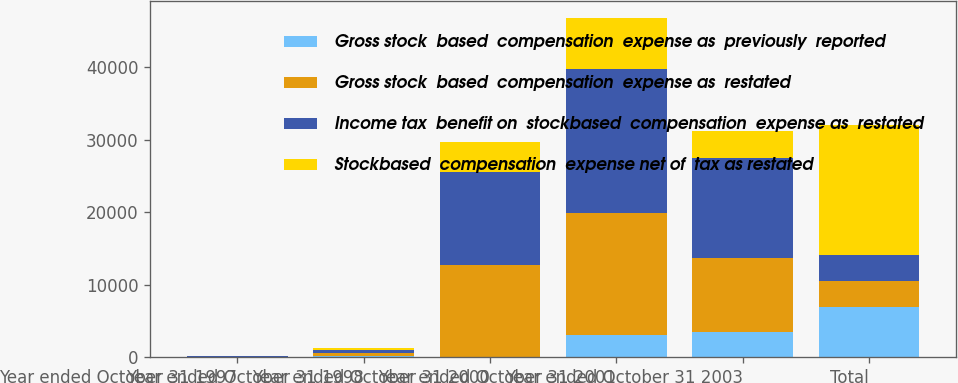Convert chart to OTSL. <chart><loc_0><loc_0><loc_500><loc_500><stacked_bar_chart><ecel><fcel>Year ended October 31 1997<fcel>Year ended October 31 1998<fcel>Year ended October 31 2000<fcel>Year ended October 31 2001<fcel>Year ended October 31 2003<fcel>Total<nl><fcel>Gross stock  based  compensation  expense as  previously  reported<fcel>17<fcel>121<fcel>5<fcel>3053<fcel>3445<fcel>6865<nl><fcel>Gross stock  based  compensation  expense as  restated<fcel>76<fcel>408<fcel>12730<fcel>16799<fcel>10259<fcel>3618<nl><fcel>Income tax  benefit on  stockbased  compensation  expense as  restated<fcel>93<fcel>529<fcel>12735<fcel>19852<fcel>13704<fcel>3618<nl><fcel>Stockbased  compensation  expense net of  tax as restated<fcel>38<fcel>187<fcel>4231<fcel>7063<fcel>3791<fcel>17840<nl></chart> 